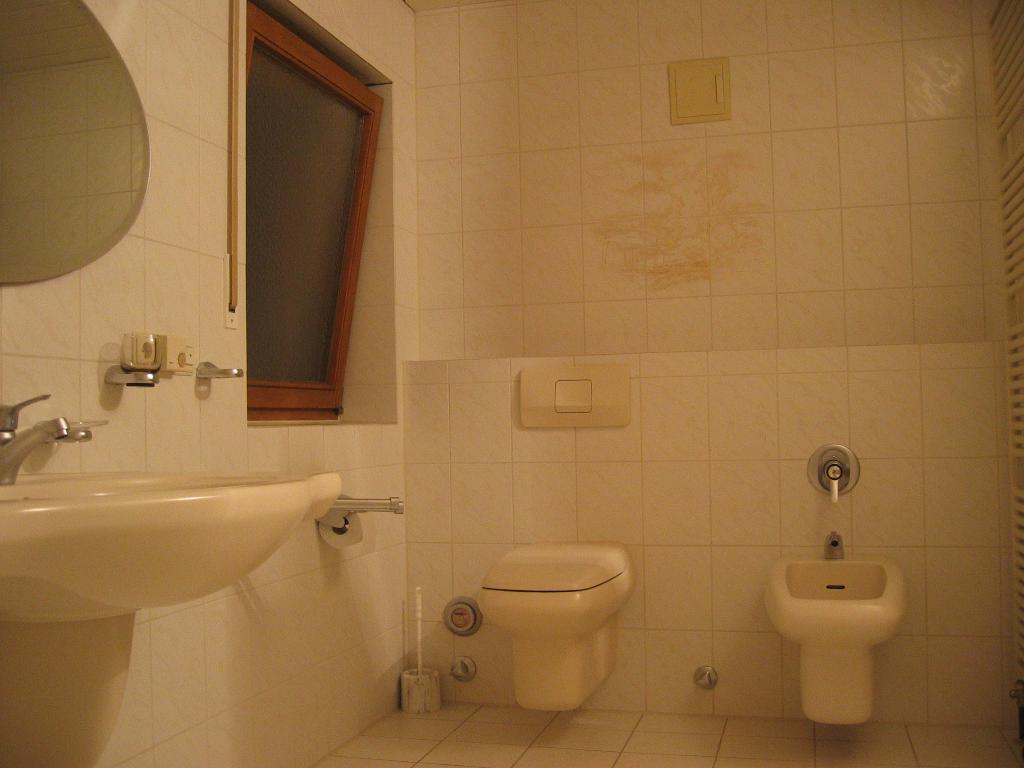How would you summarize this image in a sentence or two? In this image I can see the sink and the tap. To the side of the tape I can see the window. To the side of the window I can see the toilet. I can also see the sink and tap to the right. I can see the mirror to the wall. 